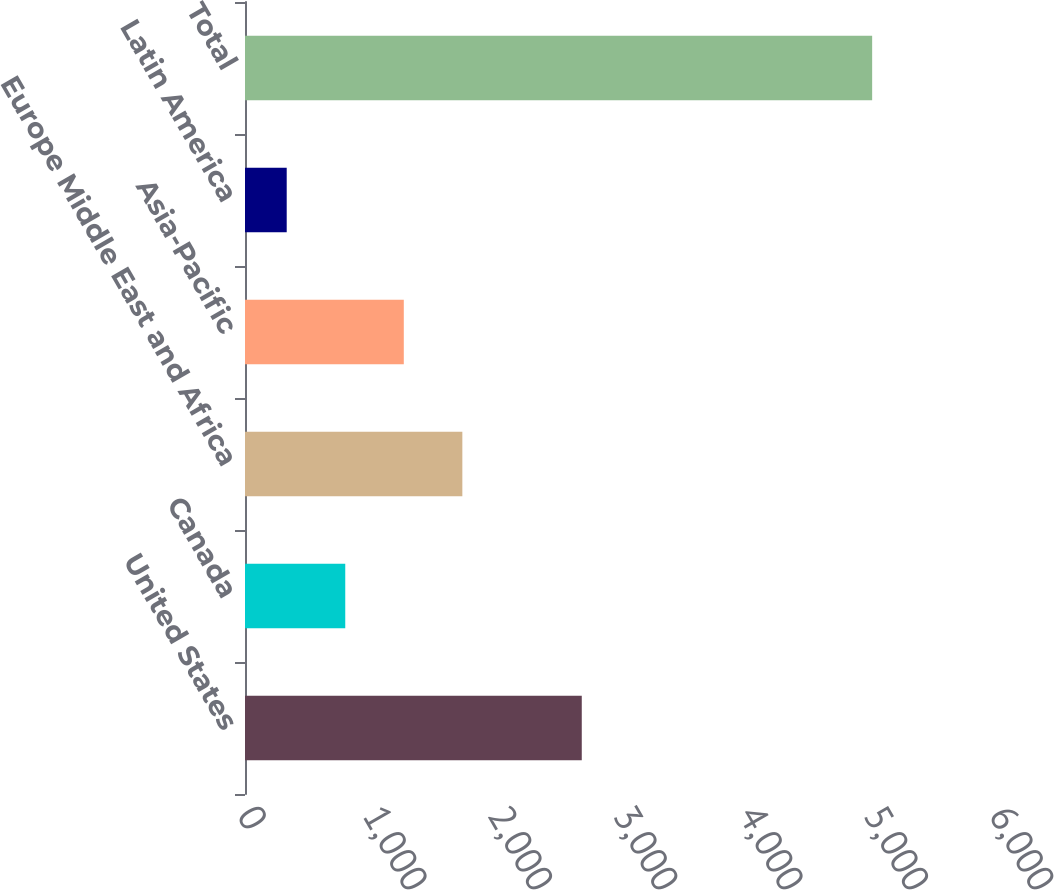Convert chart to OTSL. <chart><loc_0><loc_0><loc_500><loc_500><bar_chart><fcel>United States<fcel>Canada<fcel>Europe Middle East and Africa<fcel>Asia-Pacific<fcel>Latin America<fcel>Total<nl><fcel>2687<fcel>799.91<fcel>1734.13<fcel>1267.02<fcel>332.8<fcel>5003.9<nl></chart> 